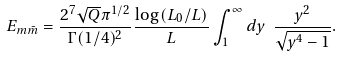<formula> <loc_0><loc_0><loc_500><loc_500>E _ { m \bar { m } } = { \frac { 2 ^ { 7 } \sqrt { Q } \pi ^ { 1 / 2 } } { \Gamma ( 1 / 4 ) ^ { 2 } } } { \frac { \log { ( L _ { 0 } / L ) } } { L } } \int _ { 1 } ^ { \infty } d y \ { \frac { y ^ { 2 } } { \sqrt { y ^ { 4 } - 1 } } } .</formula> 